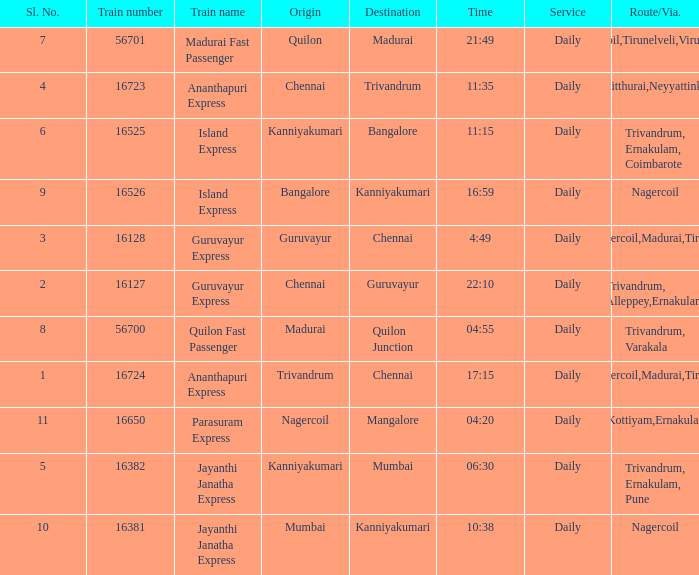Write the full table. {'header': ['Sl. No.', 'Train number', 'Train name', 'Origin', 'Destination', 'Time', 'Service', 'Route/Via.'], 'rows': [['7', '56701', 'Madurai Fast Passenger', 'Quilon', 'Madurai', '21:49', 'Daily', 'Nagercoil,Tirunelveli,Virudunagar'], ['4', '16723', 'Ananthapuri Express', 'Chennai', 'Trivandrum', '11:35', 'Daily', 'Kulitthurai,Neyyattinkara'], ['6', '16525', 'Island Express', 'Kanniyakumari', 'Bangalore', '11:15', 'Daily', 'Trivandrum, Ernakulam, Coimbarote'], ['9', '16526', 'Island Express', 'Bangalore', 'Kanniyakumari', '16:59', 'Daily', 'Nagercoil'], ['3', '16128', 'Guruvayur Express', 'Guruvayur', 'Chennai', '4:49', 'Daily', 'Nagercoil,Madurai,Tiruchi'], ['2', '16127', 'Guruvayur Express', 'Chennai', 'Guruvayur', '22:10', 'Daily', 'Trivandrum, Alleppey,Ernakulam'], ['8', '56700', 'Quilon Fast Passenger', 'Madurai', 'Quilon Junction', '04:55', 'Daily', 'Trivandrum, Varakala'], ['1', '16724', 'Ananthapuri Express', 'Trivandrum', 'Chennai', '17:15', 'Daily', 'Nagercoil,Madurai,Tiruchi'], ['11', '16650', 'Parasuram Express', 'Nagercoil', 'Mangalore', '04:20', 'Daily', 'Trivandrum,Kottiyam,Ernakulam,Kozhikode'], ['5', '16382', 'Jayanthi Janatha Express', 'Kanniyakumari', 'Mumbai', '06:30', 'Daily', 'Trivandrum, Ernakulam, Pune'], ['10', '16381', 'Jayanthi Janatha Express', 'Mumbai', 'Kanniyakumari', '10:38', 'Daily', 'Nagercoil']]} What is the train number when the time is 10:38? 16381.0. 